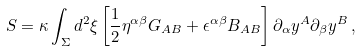<formula> <loc_0><loc_0><loc_500><loc_500>S = \kappa \int _ { \Sigma } d ^ { 2 } \xi \left [ \frac { 1 } { 2 } \eta ^ { \alpha \beta } G _ { A B } + \epsilon ^ { \alpha \beta } B _ { A B } \right ] \partial _ { \alpha } y ^ { A } \partial _ { \beta } y ^ { B } \, ,</formula> 